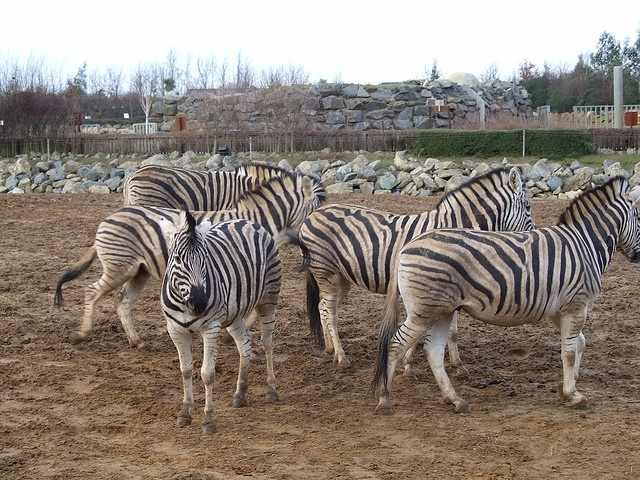Describe the objects in this image and their specific colors. I can see zebra in white, gray, darkgray, and black tones, zebra in white, gray, darkgray, black, and tan tones, zebra in white, gray, darkgray, and black tones, zebra in white, gray, darkgray, black, and tan tones, and zebra in white, gray, darkgray, and black tones in this image. 